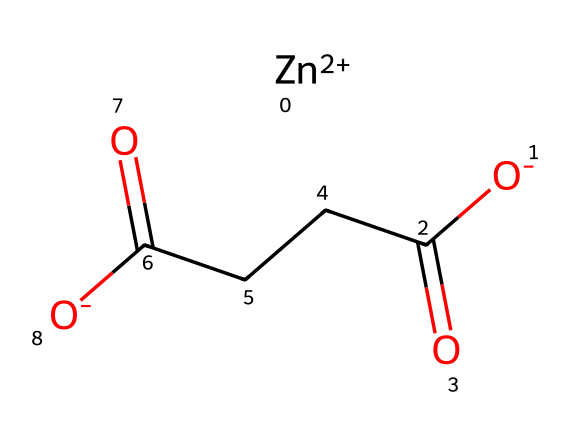What is the oxidation state of zinc in this compound? The SMILES notation shows [Zn+2], indicating that zinc has a charge of +2 in this compound. This is the oxidation state, which is represented by the positive number next to the Zn symbol.
Answer: +2 How many carbon atoms are present in this chemical structure? By analyzing the SMILES notation, we can see that there are three carbon atoms in the segment CCC. This segment clearly indicates the presence of three carbon atoms in a chain.
Answer: 3 What type of bond is present between zinc and the oxygen in this compound? The interaction between zinc ion and the negatively charged oxygen ([O-]) indicates that it forms an ionic bond, as zinc is a metal and oxygen is a non-metal with a charge.
Answer: ionic What functional groups are identified in this chemical structure? The structure has two carboxylate groups (–COO-) represented by C(=O)[O-], indicating the presence of carboxylic acids, which are functional groups known for their acidic properties.
Answer: carboxylate How many double bonds are present in the chemical? The structure indicates two double bonds, particularly with the two occurrences of C(=O), which represent the double bonds between carbon and oxygen in the carboxylate groups.
Answer: 2 What type of chemical is zinc classified as? Zinc is classified as a metal. The notation [Zn+2] confirms its metallic nature as it represents the ionic form of zinc typically found in chemical applications.
Answer: metal What is the implication of zinc's oxidation state for its reactivity in this compound? Zinc's +2 oxidation state implies it can easily participate in chemical reactions, such as forming complexes, which can enhance the effectiveness of the anti-chafing properties of the cream.
Answer: enhances reactivity 